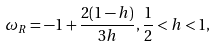Convert formula to latex. <formula><loc_0><loc_0><loc_500><loc_500>\omega _ { R } = - 1 + \frac { 2 ( 1 - h ) } { 3 h } , \frac { 1 } { 2 } < h < 1 ,</formula> 